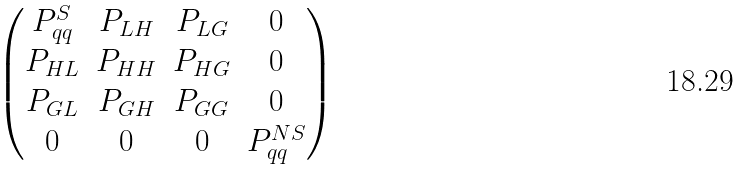<formula> <loc_0><loc_0><loc_500><loc_500>\begin{pmatrix} P _ { q q } ^ { S } & P _ { L H } & P _ { L G } & 0 \\ P _ { H L } & P _ { H H } & P _ { H G } & 0 \\ P _ { G L } & P _ { G H } & P _ { G G } & 0 \\ 0 & 0 & 0 & P _ { q q } ^ { N S } \end{pmatrix}</formula> 